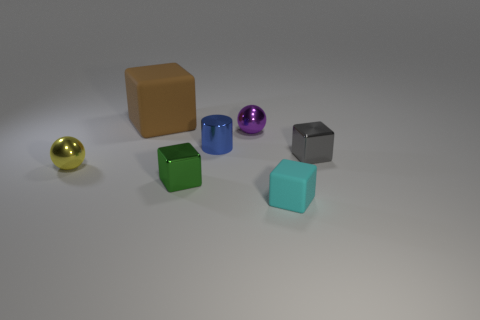There is a metal cube on the left side of the gray shiny block; is its size the same as the yellow shiny ball?
Give a very brief answer. Yes. The purple thing that is the same size as the gray thing is what shape?
Provide a short and direct response. Sphere. Is the shape of the big object the same as the tiny rubber object?
Your answer should be compact. Yes. How many tiny gray metallic things have the same shape as the large matte thing?
Your response must be concise. 1. What number of large matte things are in front of the yellow sphere?
Offer a terse response. 0. How many blue objects have the same size as the cyan matte block?
Make the answer very short. 1. What shape is the purple object that is made of the same material as the yellow ball?
Your answer should be very brief. Sphere. What is the material of the yellow ball?
Make the answer very short. Metal. What number of things are either large cyan spheres or blue shiny cylinders?
Offer a very short reply. 1. There is a rubber thing in front of the small yellow shiny object; what size is it?
Keep it short and to the point. Small. 